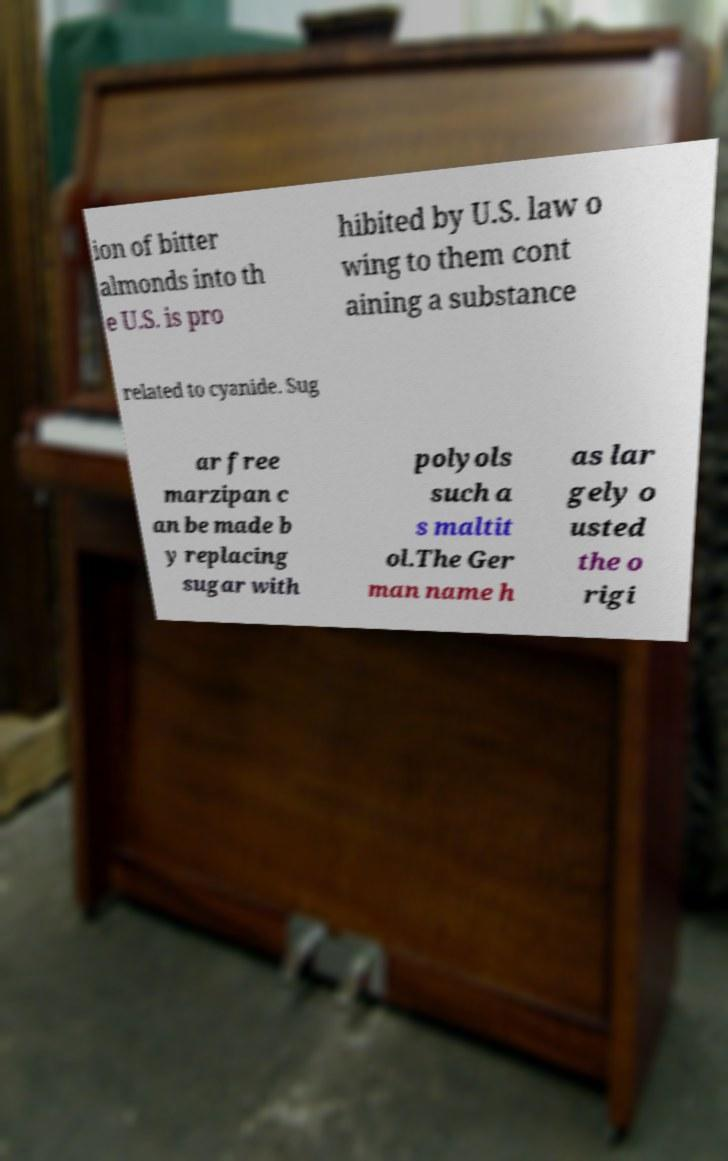What messages or text are displayed in this image? I need them in a readable, typed format. ion of bitter almonds into th e U.S. is pro hibited by U.S. law o wing to them cont aining a substance related to cyanide. Sug ar free marzipan c an be made b y replacing sugar with polyols such a s maltit ol.The Ger man name h as lar gely o usted the o rigi 